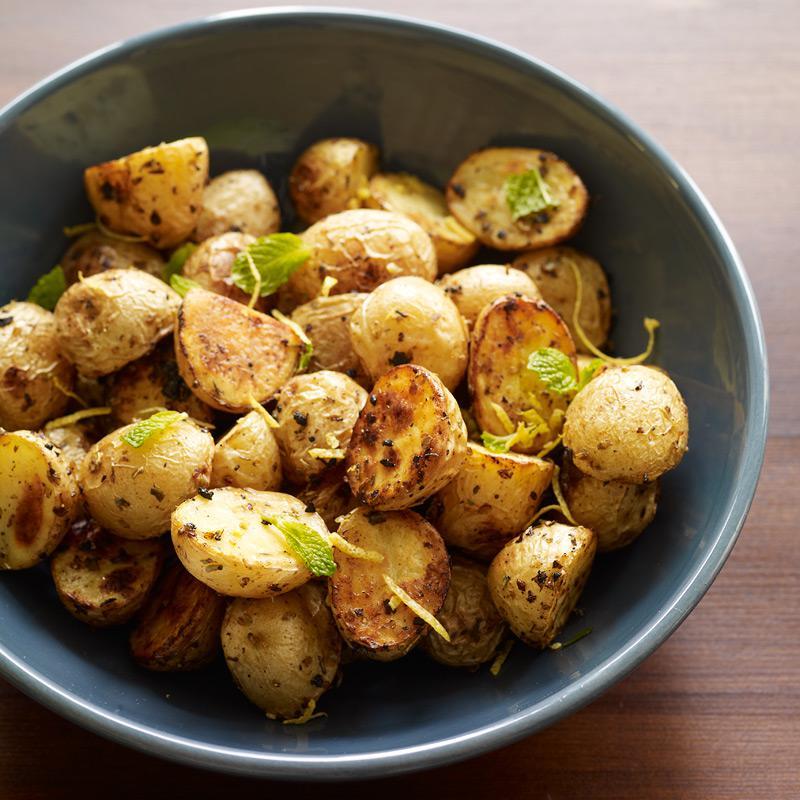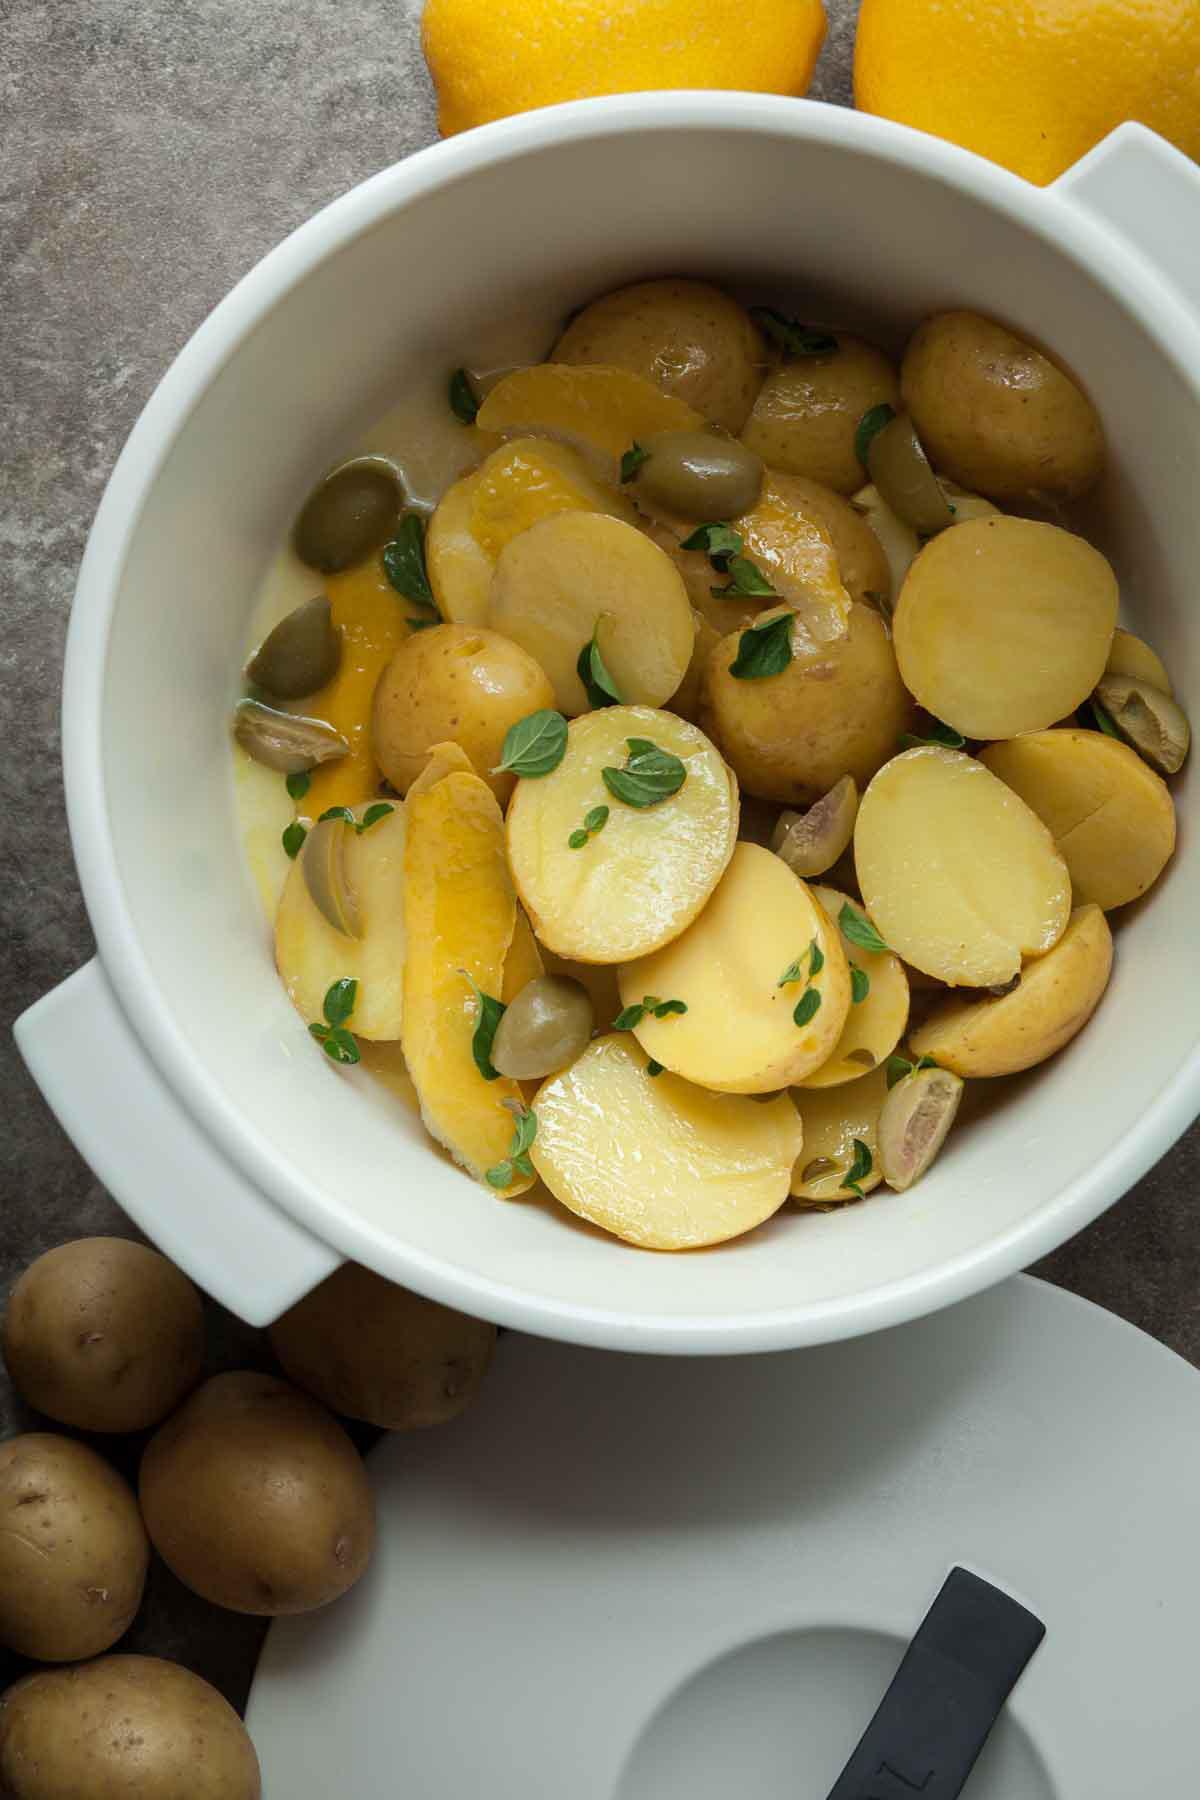The first image is the image on the left, the second image is the image on the right. Evaluate the accuracy of this statement regarding the images: "The left image shows a round bowl without handles containing potato sections, and the right image shows a white interiored dish with handles containing sliced potato pieces.". Is it true? Answer yes or no. Yes. The first image is the image on the left, the second image is the image on the right. Analyze the images presented: Is the assertion "Both food items are in bowls." valid? Answer yes or no. Yes. 